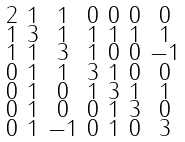Convert formula to latex. <formula><loc_0><loc_0><loc_500><loc_500>\begin{smallmatrix} 2 & 1 & 1 & 0 & 0 & 0 & 0 \\ 1 & 3 & 1 & 1 & 1 & 1 & 1 \\ 1 & 1 & 3 & 1 & 0 & 0 & - 1 \\ 0 & 1 & 1 & 3 & 1 & 0 & 0 \\ 0 & 1 & 0 & 1 & 3 & 1 & 1 \\ 0 & 1 & 0 & 0 & 1 & 3 & 0 \\ 0 & 1 & - 1 & 0 & 1 & 0 & 3 \end{smallmatrix}</formula> 